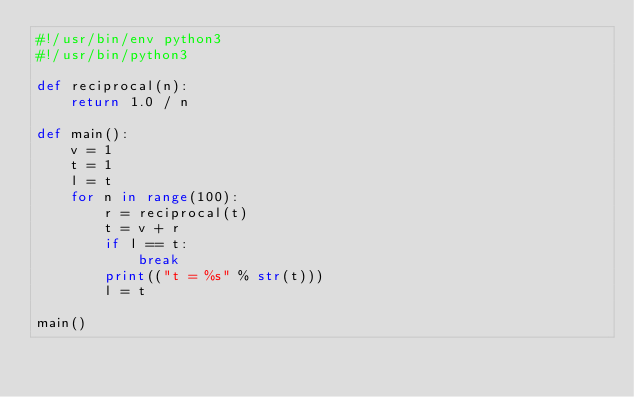Convert code to text. <code><loc_0><loc_0><loc_500><loc_500><_Python_>#!/usr/bin/env python3
#!/usr/bin/python3

def reciprocal(n):
    return 1.0 / n

def main():
    v = 1
    t = 1
    l = t
    for n in range(100):
        r = reciprocal(t)
        t = v + r
        if l == t:
            break
        print(("t = %s" % str(t)))
        l = t

main()
</code> 